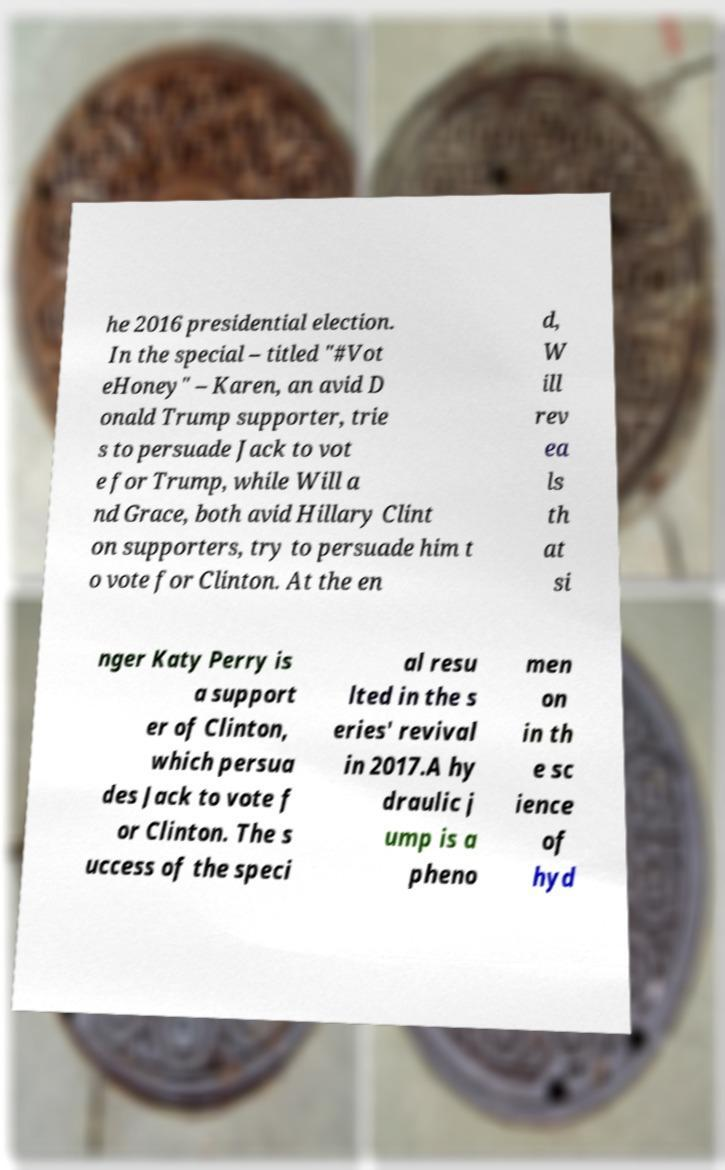Could you extract and type out the text from this image? he 2016 presidential election. In the special – titled "#Vot eHoney" – Karen, an avid D onald Trump supporter, trie s to persuade Jack to vot e for Trump, while Will a nd Grace, both avid Hillary Clint on supporters, try to persuade him t o vote for Clinton. At the en d, W ill rev ea ls th at si nger Katy Perry is a support er of Clinton, which persua des Jack to vote f or Clinton. The s uccess of the speci al resu lted in the s eries' revival in 2017.A hy draulic j ump is a pheno men on in th e sc ience of hyd 